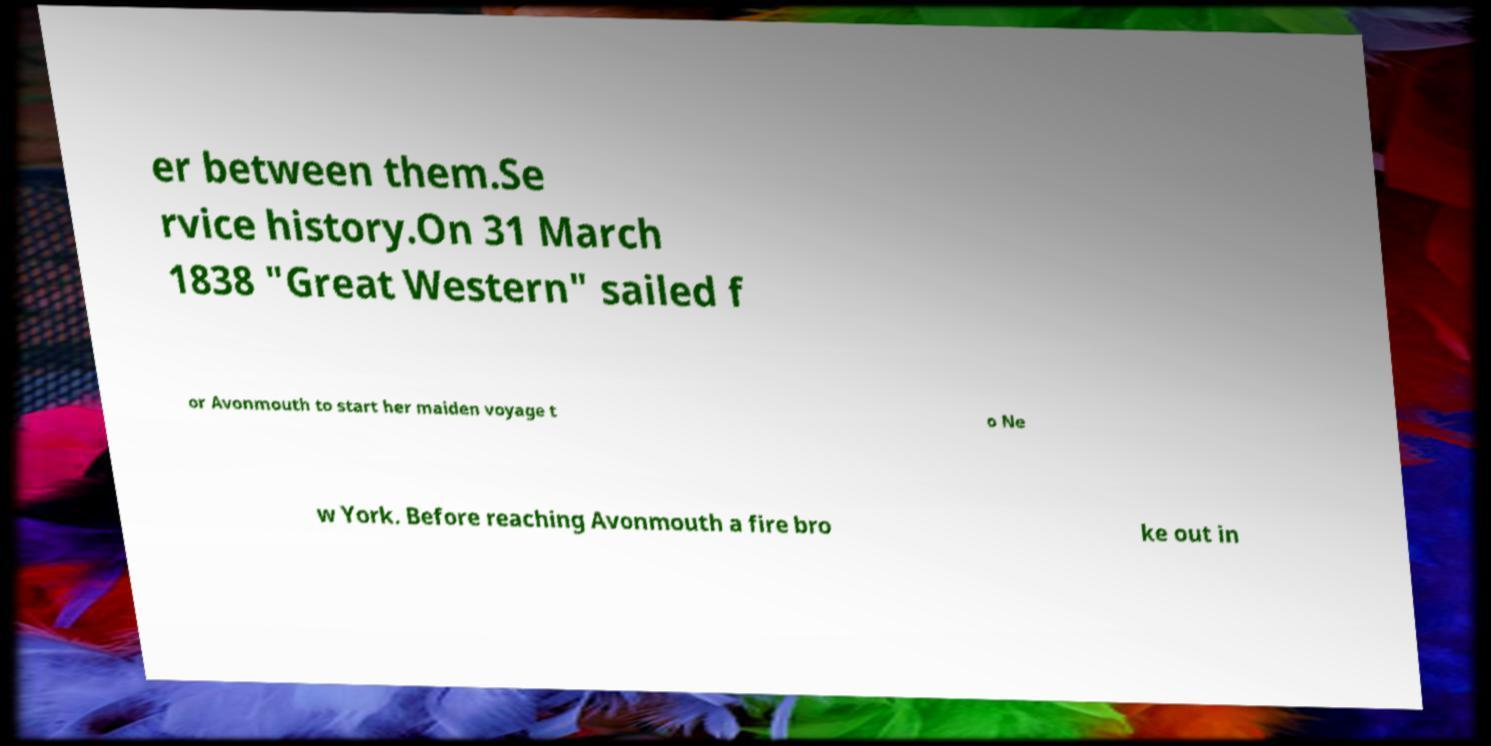Please identify and transcribe the text found in this image. er between them.Se rvice history.On 31 March 1838 "Great Western" sailed f or Avonmouth to start her maiden voyage t o Ne w York. Before reaching Avonmouth a fire bro ke out in 